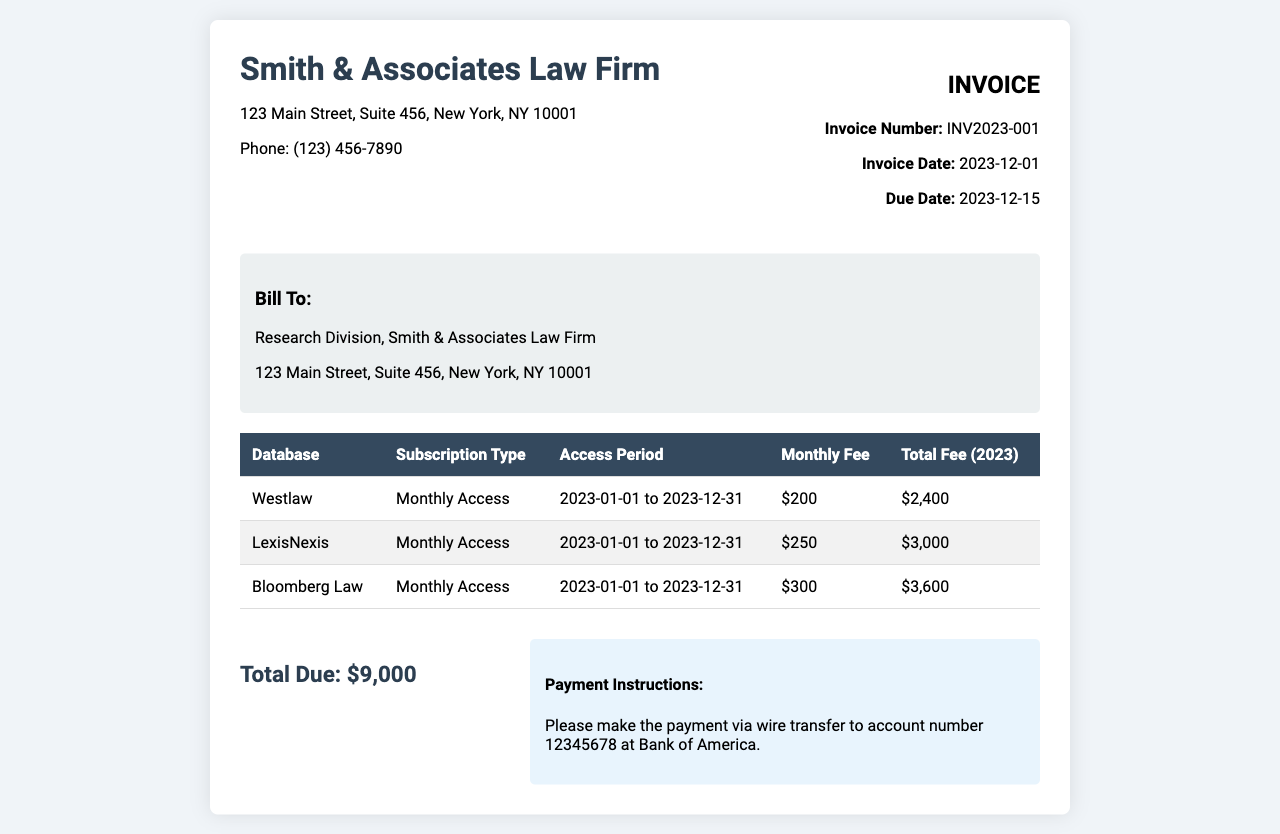What is the invoice number? The invoice number can be found in the invoice info section and is typically used for tracking payments.
Answer: INV2023-001 What is the total due amount? The total due amount is the sum displayed at the end of the invoice summary section.
Answer: $9,000 What is the monthly fee for LexisNexis? The monthly fee for LexisNexis is listed in the subscription service breakdown table.
Answer: $250 What is the access period for Bloomberg Law? The access period indicates how long the subscription is valid, as shown in the subscription table.
Answer: 2023-01-01 to 2023-12-31 What type of access does Westlaw offer? The subscription type for Westlaw is specified in the table describing the different databases and their access types.
Answer: Monthly Access How many different databases are listed? The total number of databases included in the invoice highlights how many research tools are being billed.
Answer: 3 When is the payment due date? The due date for the payment is mentioned in the invoice info section, indicating when payment should be made.
Answer: 2023-12-15 What is the total fee for Bloomberg Law? The total fee for Bloomberg Law indicates the total charged for that specific service for the year.
Answer: $3,600 Who is the invoice billed to? The billing information section specifies the entity responsible for the payment of the invoice.
Answer: Research Division, Smith & Associates Law Firm 